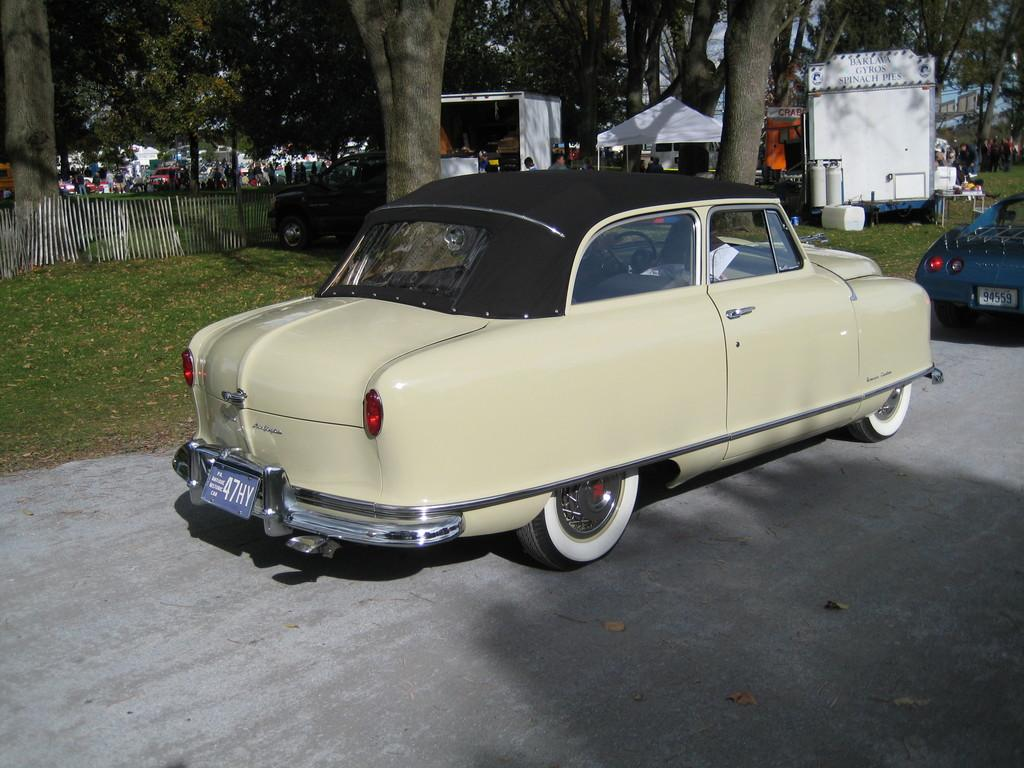What types of vehicles are parked in the image? There are cars and trucks parked in the image. What can be seen in the background of the image? There are trees visible in the image. What is the structure in the image that might be used for shelter or storage? There is a tent in the image. What type of furniture is present in the image? There is a table in the image. What type of ground surface is visible in the image? There is grass on the ground in the image. What type of barrier is present in the image? There is a wooden fence in the image. Are there any people present in the image? Yes, there are people standing in the image. What flavor of crib can be seen in the image? There is no crib present in the image, and therefore no flavor can be associated with it. What key is used to unlock the wooden fence in the image? There is no mention of a key or lock in the image, so it cannot be determined how the wooden fence is secured. 